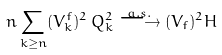Convert formula to latex. <formula><loc_0><loc_0><loc_500><loc_500>n \sum _ { k \geq n } ( V ^ { f } _ { k } ) ^ { 2 } \, Q _ { k } ^ { 2 } \stackrel { a . s . } \longrightarrow ( V _ { f } ) ^ { 2 } H</formula> 